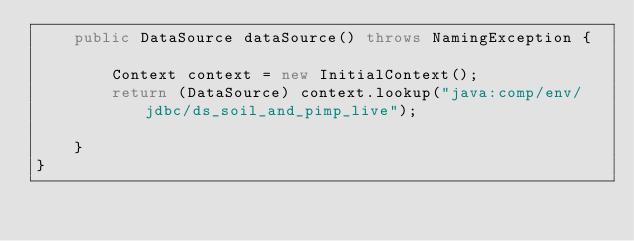Convert code to text. <code><loc_0><loc_0><loc_500><loc_500><_Java_>    public DataSource dataSource() throws NamingException {

        Context context = new InitialContext();
        return (DataSource) context.lookup("java:comp/env/jdbc/ds_soil_and_pimp_live");

    }
}
</code> 